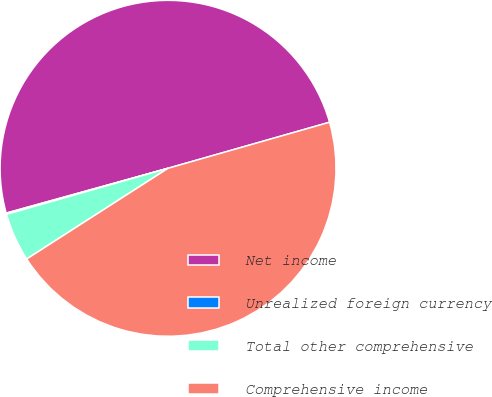<chart> <loc_0><loc_0><loc_500><loc_500><pie_chart><fcel>Net income<fcel>Unrealized foreign currency<fcel>Total other comprehensive<fcel>Comprehensive income<nl><fcel>49.88%<fcel>0.12%<fcel>4.66%<fcel>45.34%<nl></chart> 